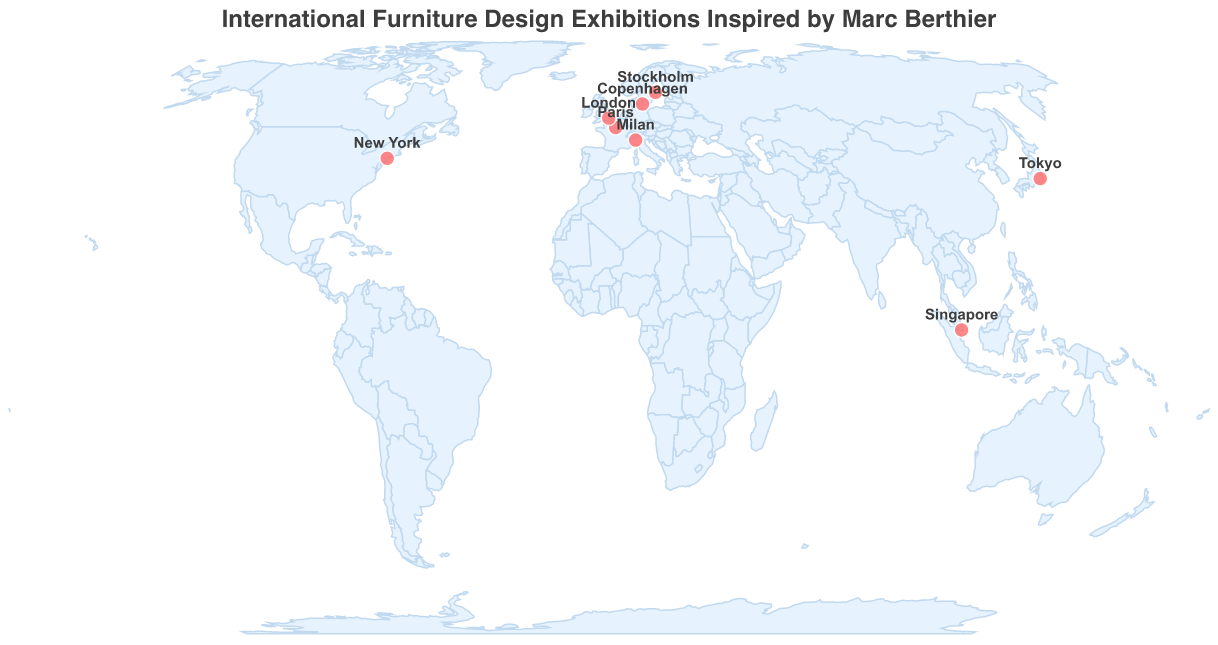Which city hosts the Salone del Mobile exhibition? The circle closest to the city of Milan indicates the location for the Salone del Mobile exhibition.
Answer: Milan What is the color of the circles representing the cities on the map? The circles representing the cities are colored red with a white stroke.
Answer: Red How many major furniture design exhibitions are displayed on the map? Count the number of circles representing the exhibitions on the map. There are eight circles.
Answer: 8 What unique Berthier-inspired work is featured in the exhibition held in Paris? The tooltip information for Paris shows the name of the featured work as "Elysée Chair modern variant."
Answer: Elysée Chair modern variant What is the westernmost city hosting a major furniture design exhibition? Locate the circle furthest to the left (westward direction) on the map. New York is the westernmost city.
Answer: New York Which exhibition is held in Tokyo, and what Berthier-inspired work is showcased? The tooltip information for Tokyo reveals that the Tokyo Design Week features an "M400 watch-inspired timepiece."
Answer: Tokyo Design Week, M400 watch-inspired timepiece How many exhibitions are held in Europe? Identify all circles located in Europe and count them. The cities are Milan, Paris, Copenhagen, London, and Stockholm, making a total of five exhibitions.
Answer: 5 Which cities are closest in latitude? Compare latitude values of all the cities. London (51.5074) and Paris (48.8566) are the closest in latitude.
Answer: London and Paris Which cities have design exhibitions featuring reinterpreted or reimagined versions of Marc Berthier's original designs? Analyze the 'Featured Berthier-inspired Work' field to identify reinterpreted or reimagined works. Milan and New York feature "Tykho Radio reinterpretation" and "Dupleix lamp reimagined," respectively.
Answer: Milan and New York 